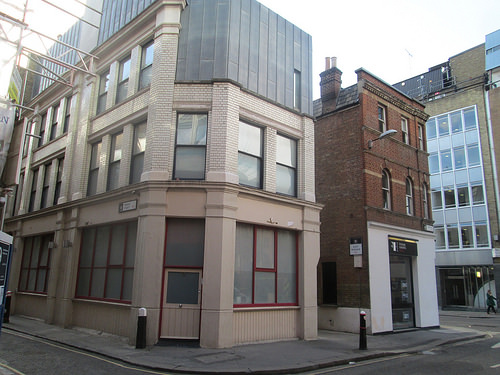<image>
Is there a sky behind the building? Yes. From this viewpoint, the sky is positioned behind the building, with the building partially or fully occluding the sky. Where is the building in relation to the building? Is it behind the building? No. The building is not behind the building. From this viewpoint, the building appears to be positioned elsewhere in the scene. 